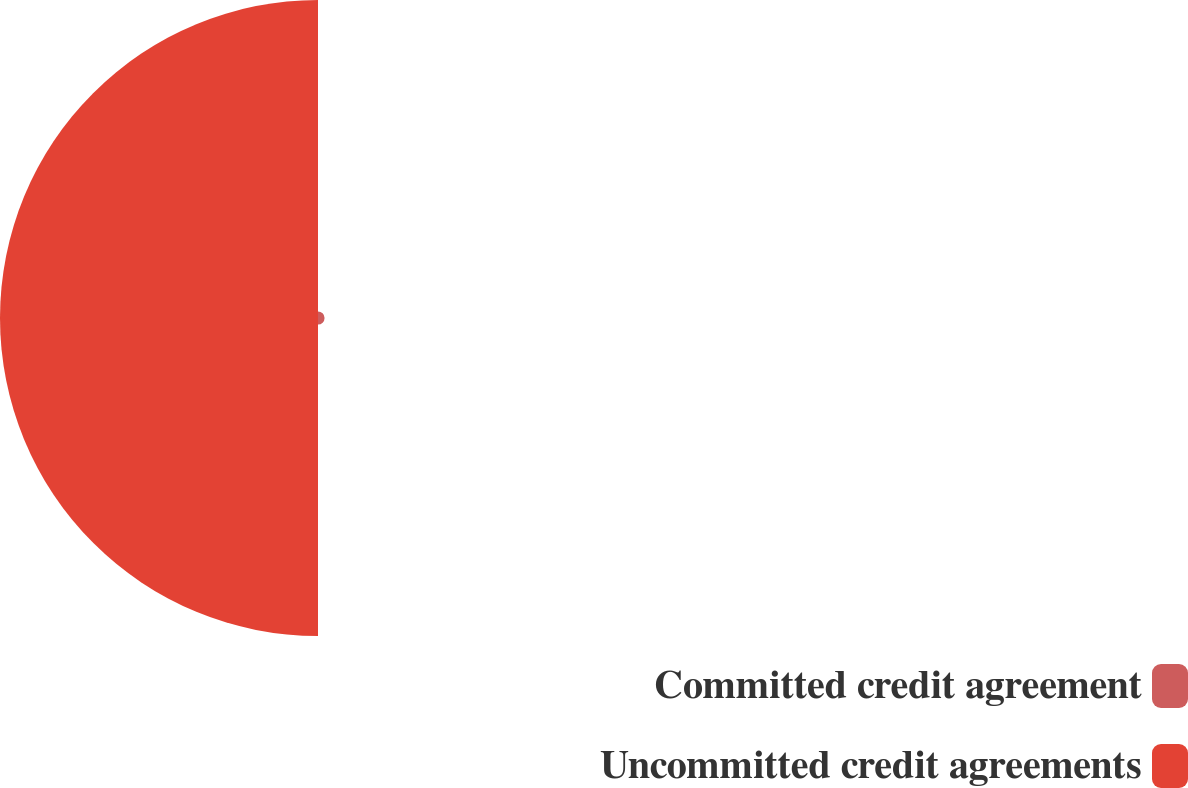Convert chart to OTSL. <chart><loc_0><loc_0><loc_500><loc_500><pie_chart><fcel>Committed credit agreement<fcel>Uncommitted credit agreements<nl><fcel>2.02%<fcel>97.98%<nl></chart> 